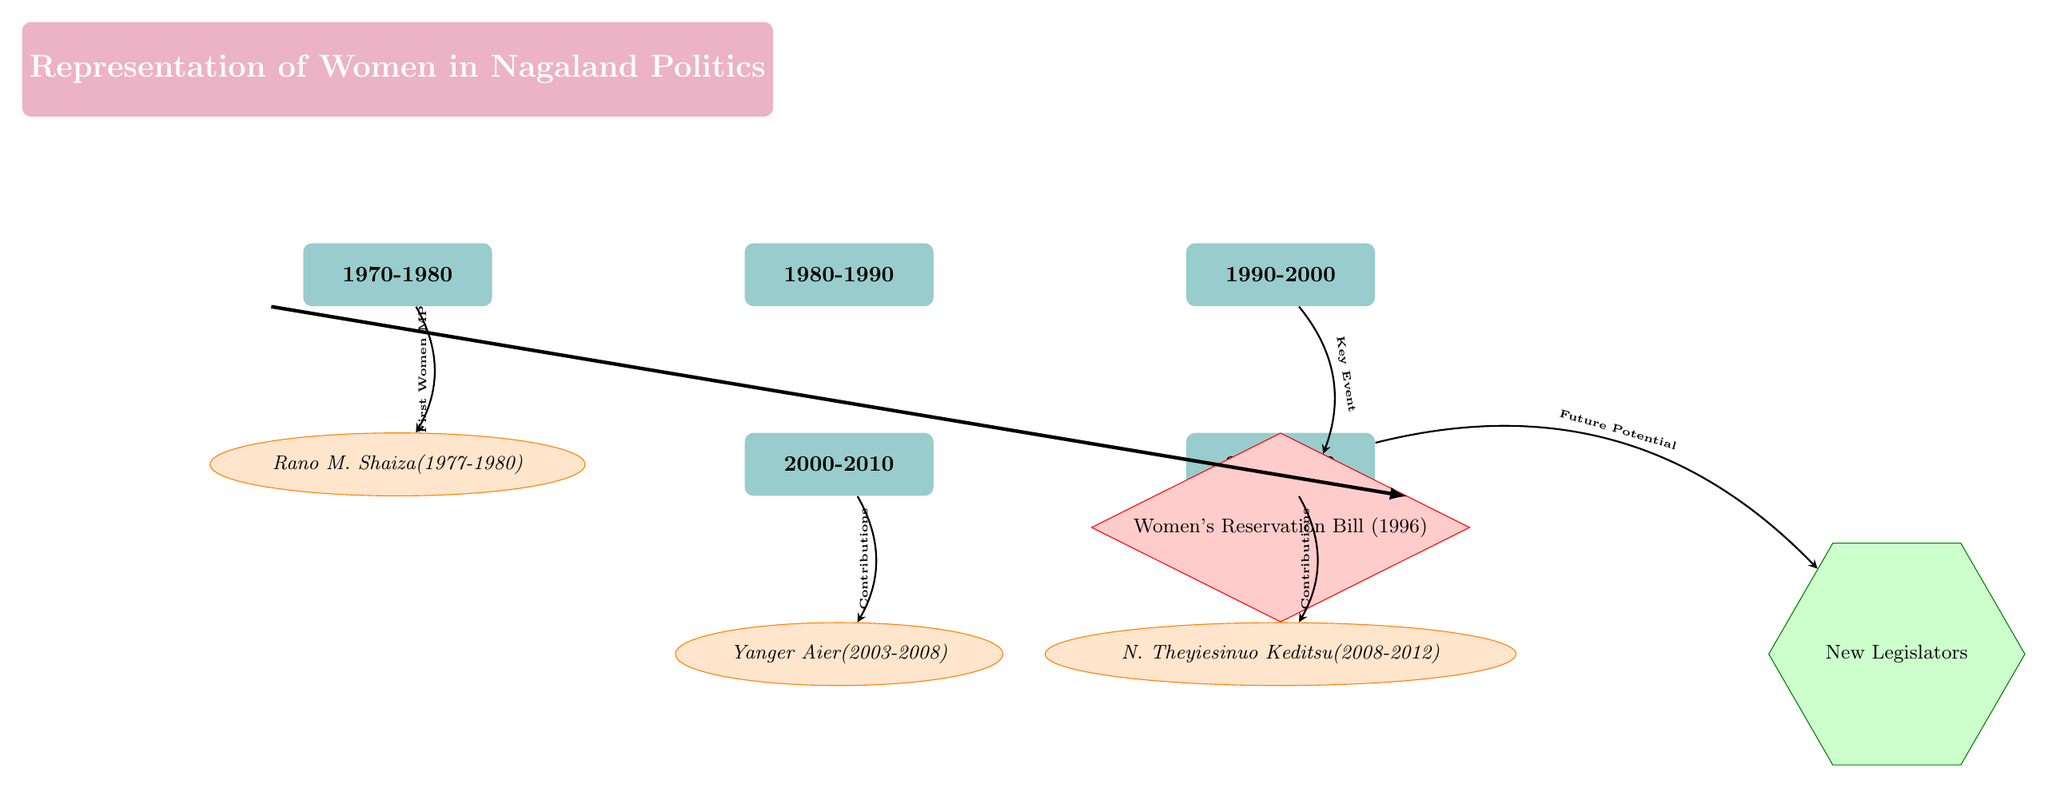What decade does Rano M. Shaiza serve as a leader? Rano M. Shaiza's tenure as a political leader is indicated directly below the decade label "1970-1980." Therefore, the decade during which she served is the 1970s.
Answer: 1970-1980 How many female leaders are depicted in the diagram? The diagram features a total of three female leaders: Rano M. Shaiza, Yanger Aier, and N. Theyiesinuo Keditsu. Counting each leader shown, we can determine there are three.
Answer: 3 What key event is noted in the 1990s? The key event highlighted in the 1990s is the "Women's Reservation Bill (1996)," which is specified directly under the decade label "1990-2000."
Answer: Women's Reservation Bill (1996) Which female leader served from 2003 to 2008? According to the diagram, Yanger Aier served as a leader during the term indicated by the label "2000-2010," specifically with the dates shown as 2003-2008 directly beneath her name.
Answer: Yanger Aier What potential contribution is indicated for the 2010-2020 decade? The diagram indicates "Future Potential" for "New Legislators" arising from the contributions made during the 2010-2020 timeframe. This is shown with an arrow leading from the 2010 decade to the new category.
Answer: Future Potential Which leader is associated with the first women MP designation? The first women MP designation is directly linked to Rano M. Shaiza as indicated by an arrow labeled "First Women MP" pointing to her from the 1970-1980 decade label.
Answer: Rano M. Shaiza What does the arrow from the 2010 decade point to? The arrow from the 2010 decade points to the category "New Legislators," indicating the expectation of new female politicians entering the political arena as a result of increased opportunities or changes that occurred during that decade.
Answer: New Legislators Which decade encompasses the tenure of N. Theyiesinuo Keditsu? N. Theyiesinuo Keditsu's tenure is specifically noted as running from 2008 to 2012, which is encompassed by the decade labeled "2010-2020." Therefore, her tenure falls into that decade.
Answer: 2010-2020 